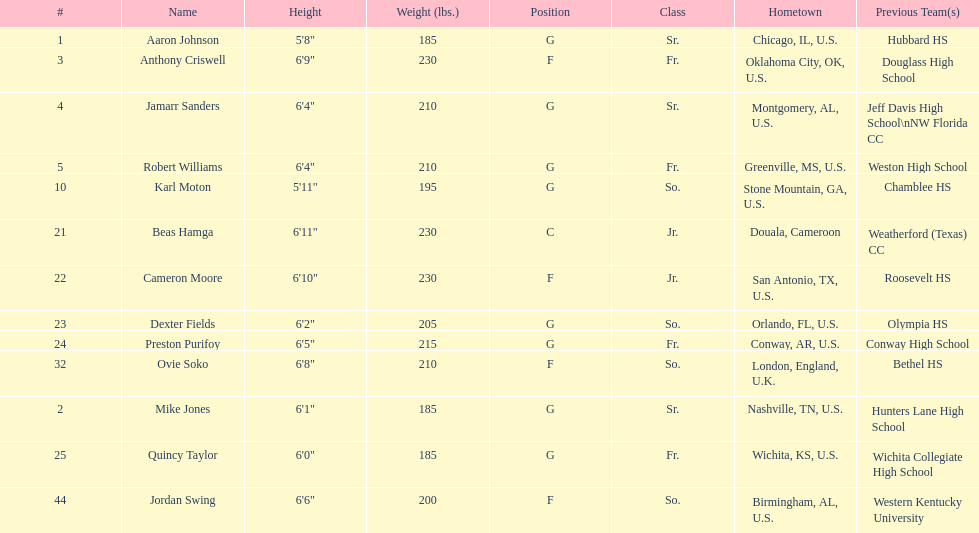What's the total count of forwards on the team? 4. 